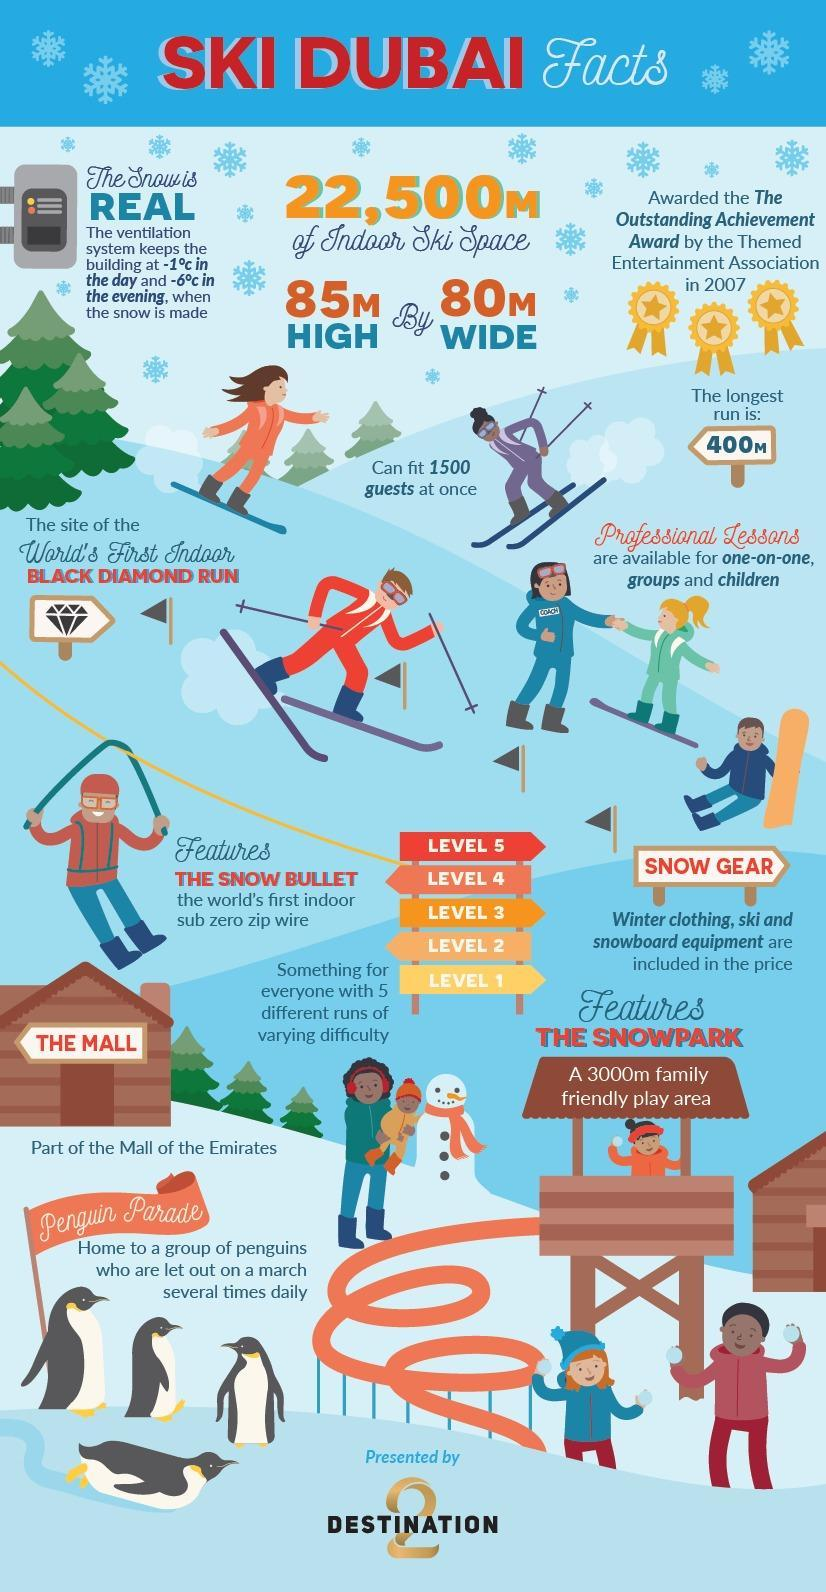How many guests can be accommodated in Ski Dubai at a time?
Answer the question with a short phrase. 1500 guests What is the indoor ski area of Ski Dubai? 22,500M 